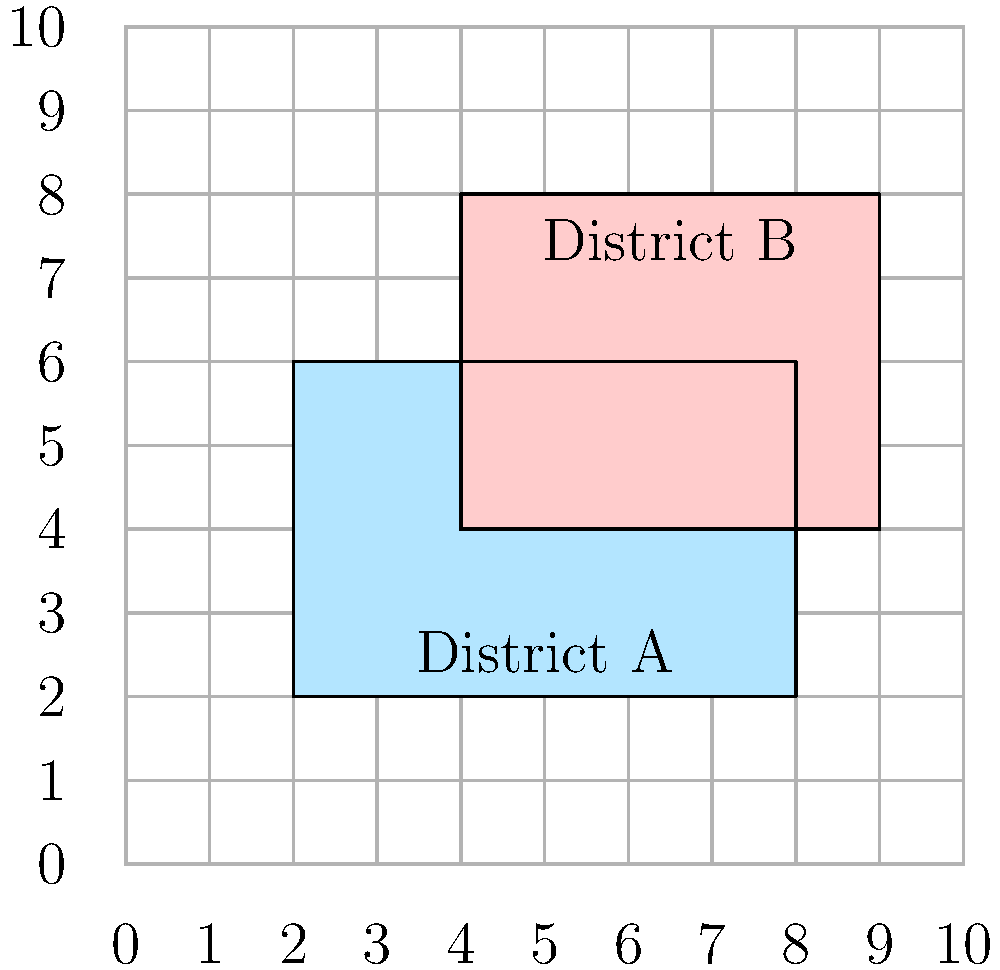In a local election, two overlapping electoral districts are represented on a grid where each unit square represents 1 square kilometer. District A is shown in blue and District B in red. Calculate the area of overlap between these two districts in square kilometers. To find the area of overlap between the two districts, we need to follow these steps:

1. Identify the coordinates of the overlapping region:
   The overlap forms a rectangle with corners at (4,4), (8,4), (8,6), and (4,6).

2. Calculate the width of the overlapping rectangle:
   Width = 8 - 4 = 4 units

3. Calculate the height of the overlapping rectangle:
   Height = 6 - 4 = 2 units

4. Calculate the area of the overlapping rectangle:
   Area = Width × Height
   Area = 4 × 2 = 8 square units

5. Since each unit square represents 1 square kilometer, the overlapping area is 8 square kilometers.

This calculation is crucial for understanding the extent of shared jurisdiction between the two electoral districts, which could impact resource allocation, voter registration, and campaign strategies in the upcoming local election.
Answer: 8 square kilometers 